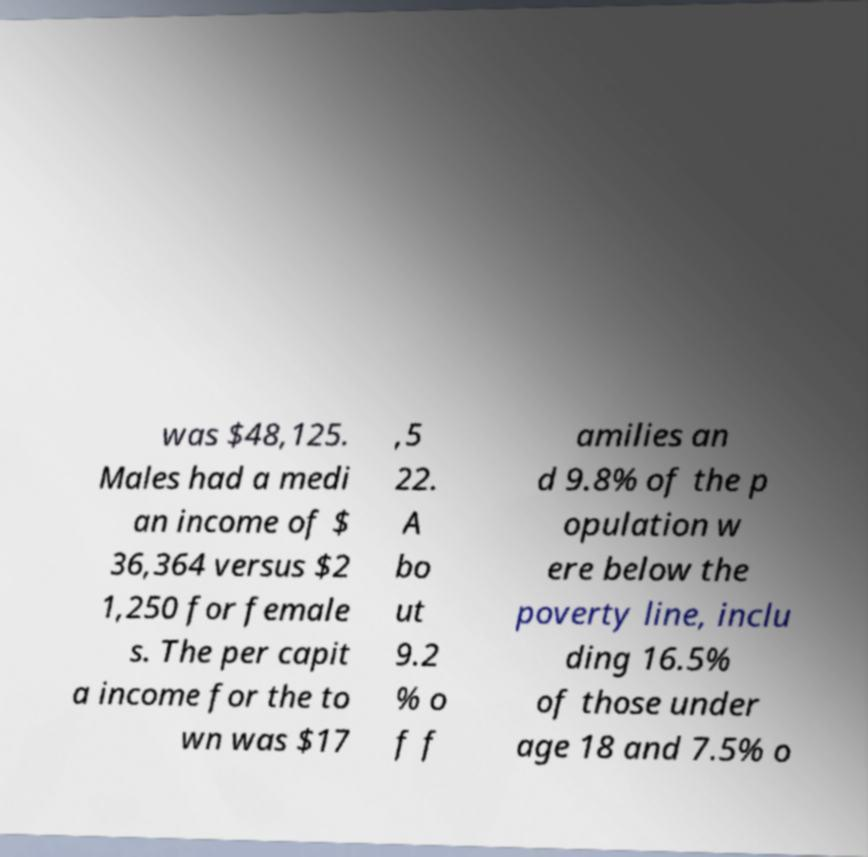Can you accurately transcribe the text from the provided image for me? was $48,125. Males had a medi an income of $ 36,364 versus $2 1,250 for female s. The per capit a income for the to wn was $17 ,5 22. A bo ut 9.2 % o f f amilies an d 9.8% of the p opulation w ere below the poverty line, inclu ding 16.5% of those under age 18 and 7.5% o 